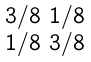<formula> <loc_0><loc_0><loc_500><loc_500>\begin{smallmatrix} 3 / 8 & 1 / 8 \\ 1 / 8 & 3 / 8 \end{smallmatrix}</formula> 